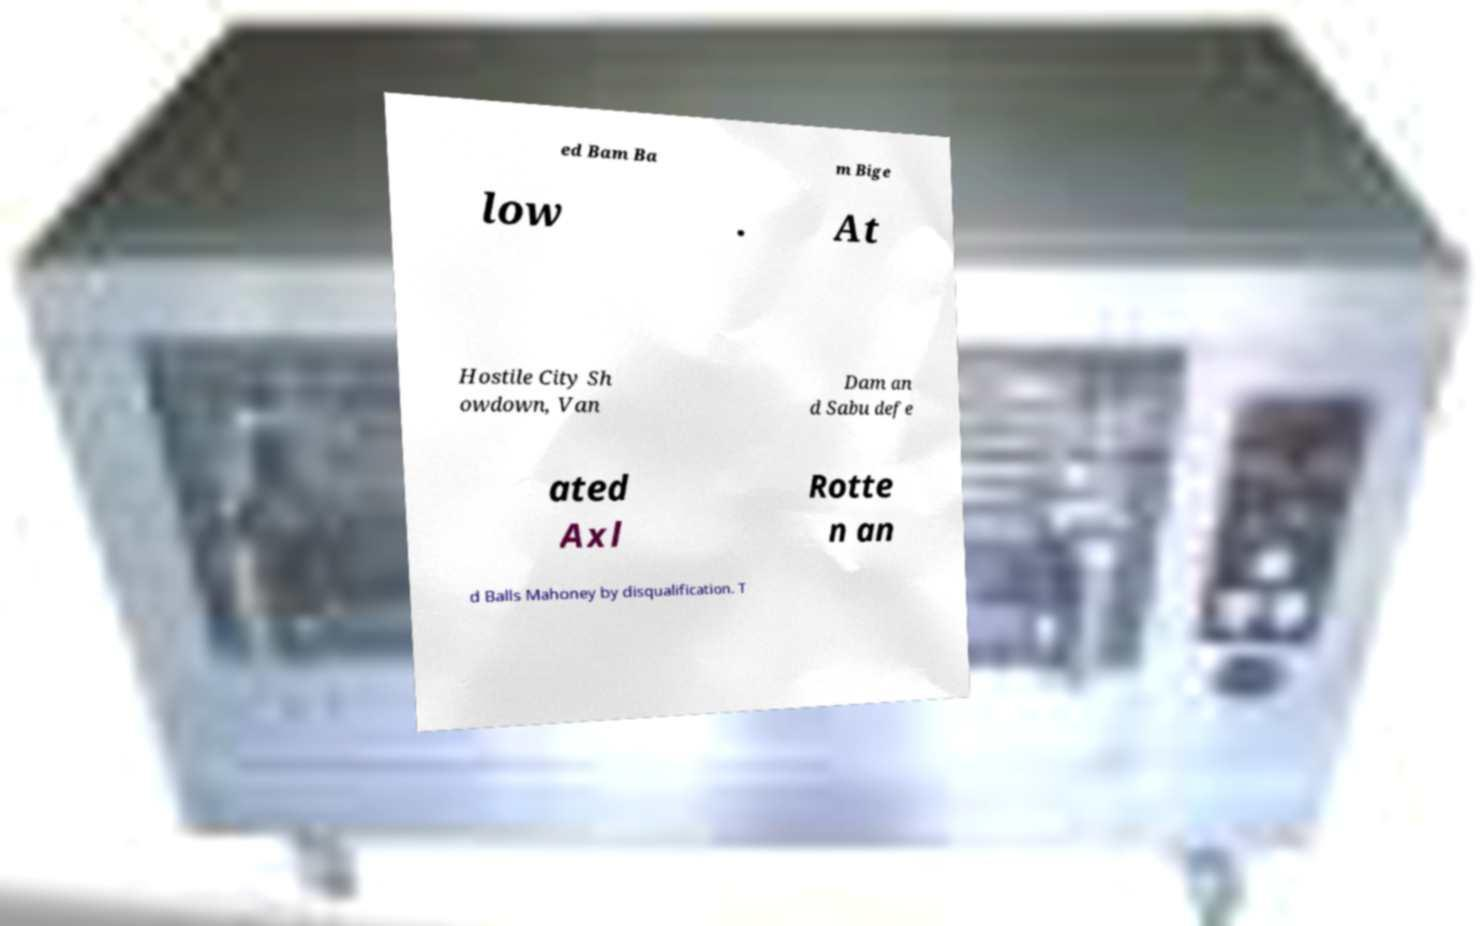There's text embedded in this image that I need extracted. Can you transcribe it verbatim? ed Bam Ba m Bige low . At Hostile City Sh owdown, Van Dam an d Sabu defe ated Axl Rotte n an d Balls Mahoney by disqualification. T 